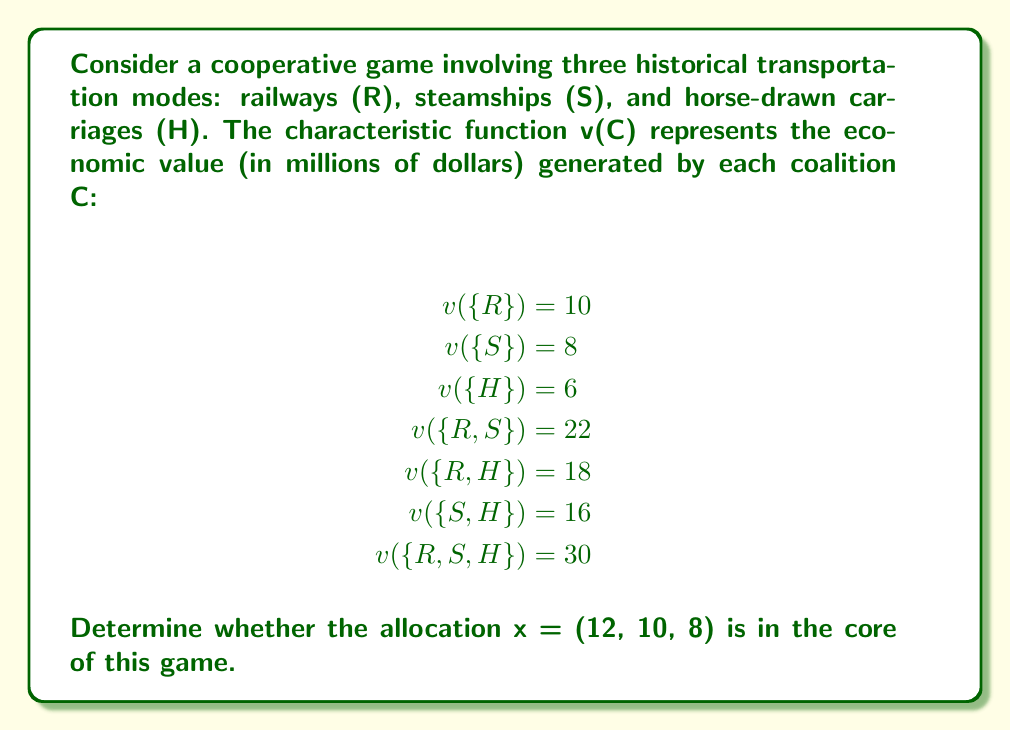Solve this math problem. To determine if the allocation x = (12, 10, 8) is in the core of the game, we need to check if it satisfies two conditions:

1. Efficiency: The sum of all allocations must equal the value of the grand coalition.
2. Stability: No coalition can improve upon this allocation.

Step 1: Check efficiency
Sum of allocations: $12 + 10 + 8 = 30$
Value of grand coalition: v({R,S,H}) = 30
The efficiency condition is satisfied.

Step 2: Check stability
We need to verify that for each coalition C:
$$\sum_{i \in C} x_i \geq v(C)$$

For singleton coalitions:
R: $12 \geq 10$
S: $10 \geq 8$
H: $8 \geq 6$

For two-player coalitions:
{R,S}: $12 + 10 = 22 \geq 22$
{R,H}: $12 + 8 = 20 \geq 18$
{S,H}: $10 + 8 = 18 \geq 16$

For the grand coalition:
{R,S,H}: $12 + 10 + 8 = 30 \geq 30$

All stability conditions are satisfied.

Since both efficiency and stability conditions are met, the allocation x = (12, 10, 8) is in the core of the game.
Answer: Yes, the allocation x = (12, 10, 8) is in the core of the cooperative game. 